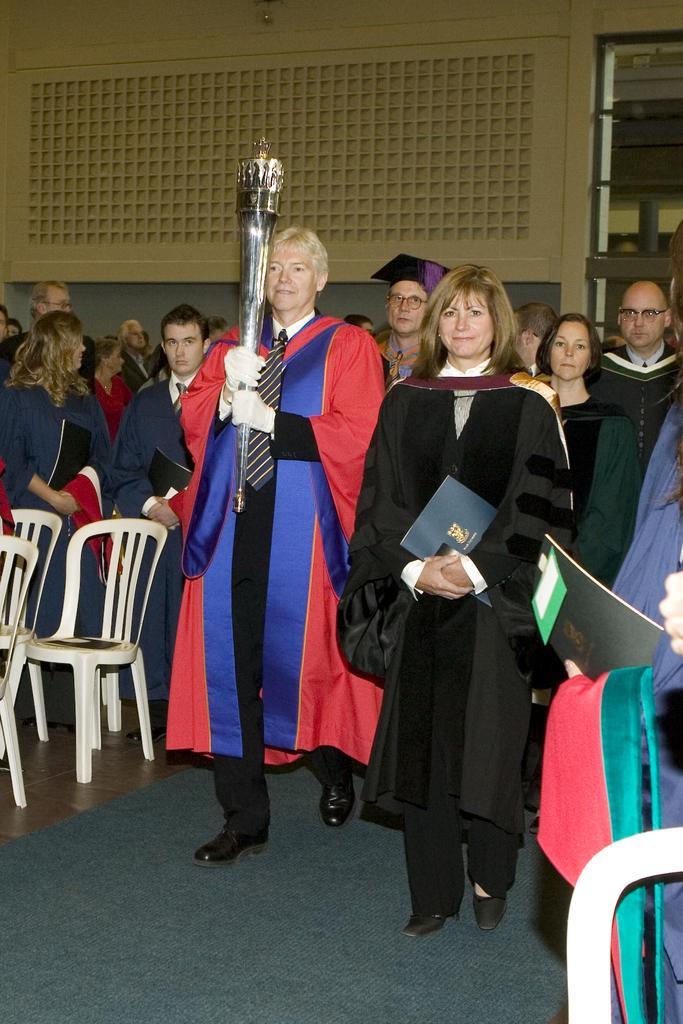In one or two sentences, can you explain what this image depicts? In this picture there is a woman walking with a lamp in her hand and there are some people walking along with her. In the background some of them was standing. We can observe a wall here. 